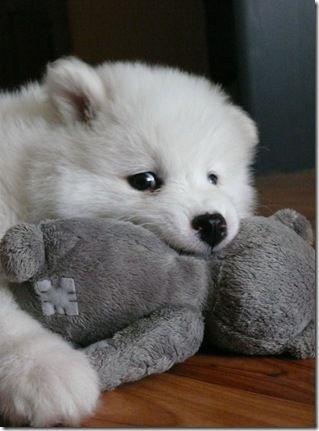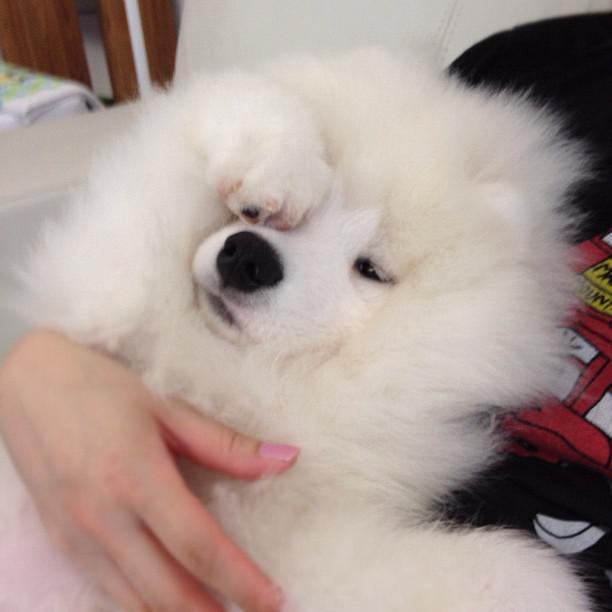The first image is the image on the left, the second image is the image on the right. Given the left and right images, does the statement "The right image contains at least one white dog with its tongue exposed." hold true? Answer yes or no. No. The first image is the image on the left, the second image is the image on the right. Analyze the images presented: Is the assertion "The combined images include two white dogs with smiling opened mouths showing pink tongues." valid? Answer yes or no. No. 